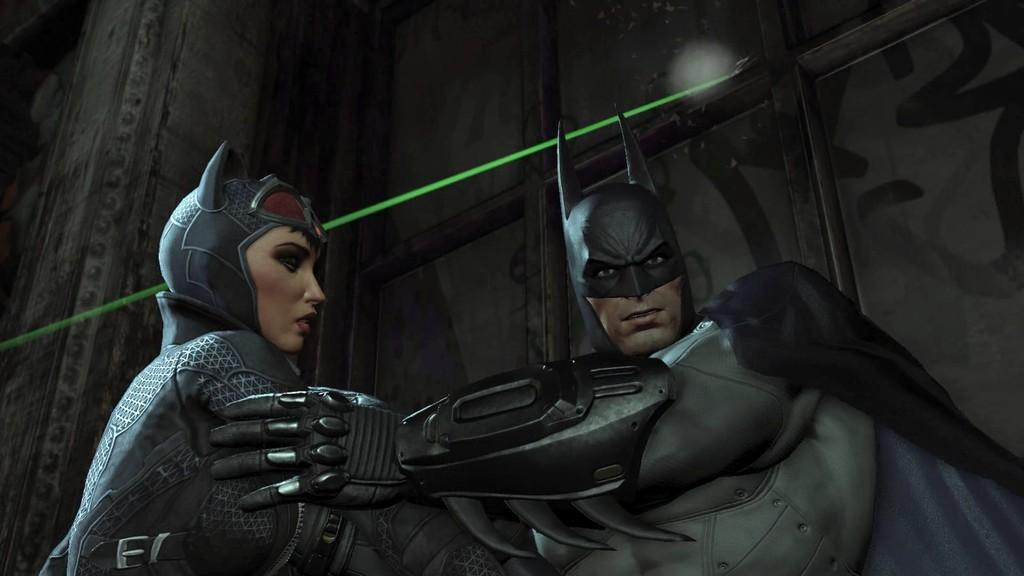What type of characters are present in the image? There are animated people in the image. What can be seen in the background of the image? There is a wall in the background of the image. What type of dinner is being served in the image? There is no dinner present in the image; it features animated people and a wall in the background. How many nails can be seen in the image? There is no mention of nails in the image, as it only features animated people and a wall in the background. 